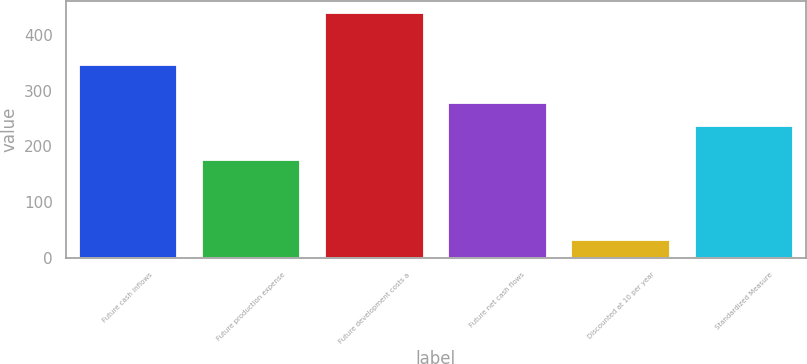Convert chart to OTSL. <chart><loc_0><loc_0><loc_500><loc_500><bar_chart><fcel>Future cash inflows<fcel>Future production expense<fcel>Future development costs a<fcel>Future net cash flows<fcel>Discounted at 10 per year<fcel>Standardized Measure<nl><fcel>345<fcel>175<fcel>439<fcel>277.7<fcel>32<fcel>237<nl></chart> 